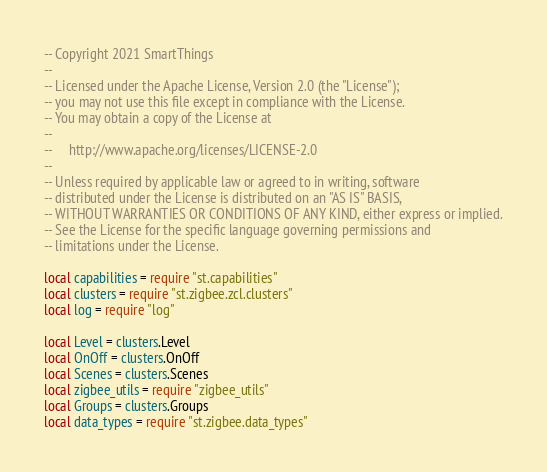Convert code to text. <code><loc_0><loc_0><loc_500><loc_500><_Lua_>-- Copyright 2021 SmartThings
--
-- Licensed under the Apache License, Version 2.0 (the "License");
-- you may not use this file except in compliance with the License.
-- You may obtain a copy of the License at
--
--     http://www.apache.org/licenses/LICENSE-2.0
--
-- Unless required by applicable law or agreed to in writing, software
-- distributed under the License is distributed on an "AS IS" BASIS,
-- WITHOUT WARRANTIES OR CONDITIONS OF ANY KIND, either express or implied.
-- See the License for the specific language governing permissions and
-- limitations under the License.

local capabilities = require "st.capabilities"
local clusters = require "st.zigbee.zcl.clusters"
local log = require "log"

local Level = clusters.Level
local OnOff = clusters.OnOff
local Scenes = clusters.Scenes
local zigbee_utils = require "zigbee_utils"
local Groups = clusters.Groups
local data_types = require "st.zigbee.data_types"</code> 